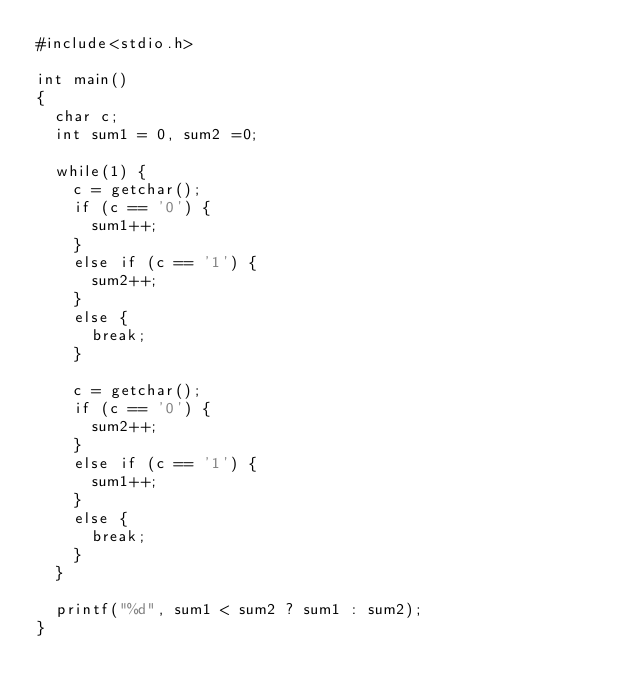Convert code to text. <code><loc_0><loc_0><loc_500><loc_500><_C_>#include<stdio.h>

int main()
{
	char c;
	int sum1 = 0, sum2 =0;

	while(1) {
		c = getchar();
		if (c == '0') {
			sum1++;
		}
		else if (c == '1') {
			sum2++;
		}
		else {
			break;
		}

		c = getchar();
		if (c == '0') {
			sum2++;
		}
		else if (c == '1') {
			sum1++;
		}
		else {
			break;
		}
	}

	printf("%d", sum1 < sum2 ? sum1 : sum2);
}</code> 